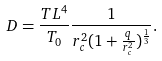Convert formula to latex. <formula><loc_0><loc_0><loc_500><loc_500>D = \frac { T L ^ { 4 } } { T _ { 0 } } \frac { 1 } { r _ { c } ^ { 2 } ( 1 + \frac { q } { r _ { c } ^ { 2 } } ) ^ { \frac { 1 } { 3 } } } .</formula> 